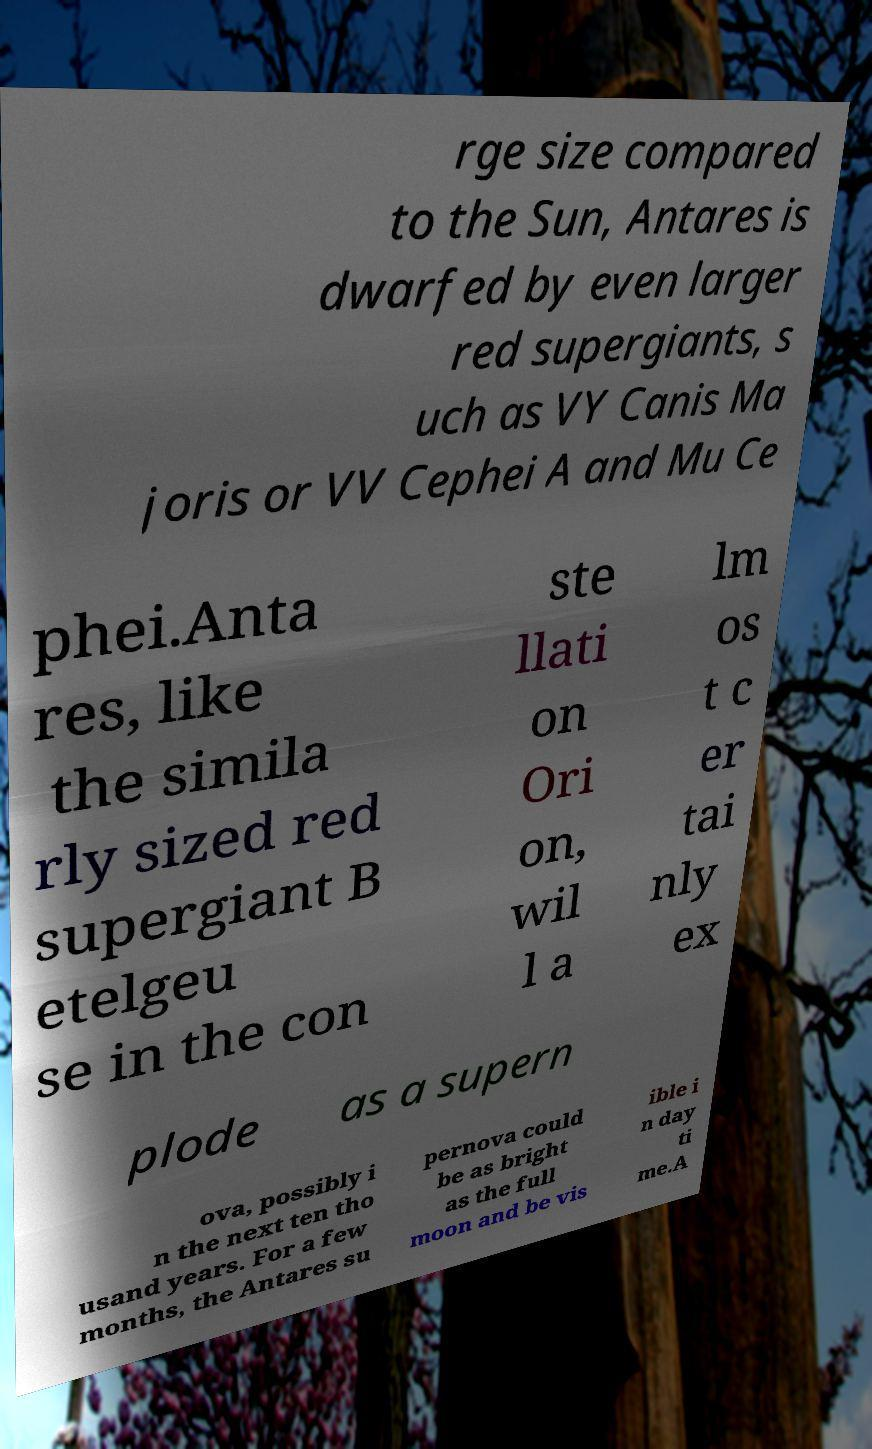What messages or text are displayed in this image? I need them in a readable, typed format. rge size compared to the Sun, Antares is dwarfed by even larger red supergiants, s uch as VY Canis Ma joris or VV Cephei A and Mu Ce phei.Anta res, like the simila rly sized red supergiant B etelgeu se in the con ste llati on Ori on, wil l a lm os t c er tai nly ex plode as a supern ova, possibly i n the next ten tho usand years. For a few months, the Antares su pernova could be as bright as the full moon and be vis ible i n day ti me.A 